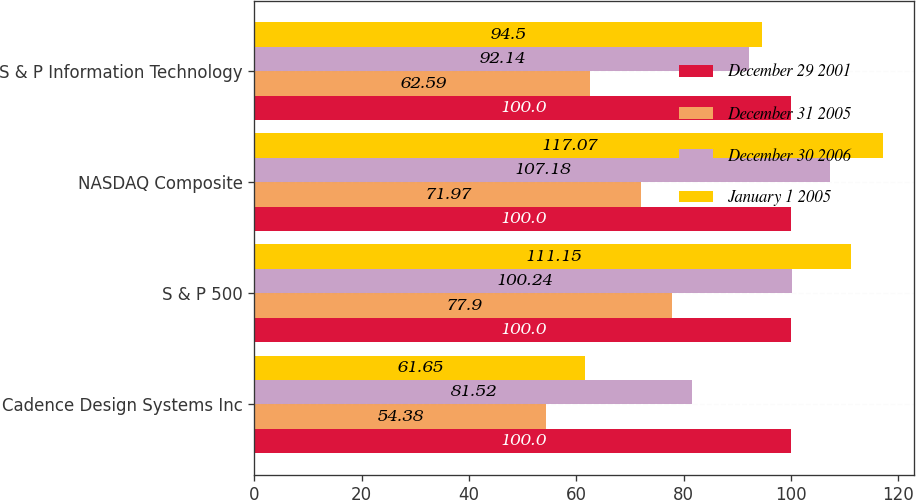Convert chart. <chart><loc_0><loc_0><loc_500><loc_500><stacked_bar_chart><ecel><fcel>Cadence Design Systems Inc<fcel>S & P 500<fcel>NASDAQ Composite<fcel>S & P Information Technology<nl><fcel>December 29 2001<fcel>100<fcel>100<fcel>100<fcel>100<nl><fcel>December 31 2005<fcel>54.38<fcel>77.9<fcel>71.97<fcel>62.59<nl><fcel>December 30 2006<fcel>81.52<fcel>100.24<fcel>107.18<fcel>92.14<nl><fcel>January 1 2005<fcel>61.65<fcel>111.15<fcel>117.07<fcel>94.5<nl></chart> 